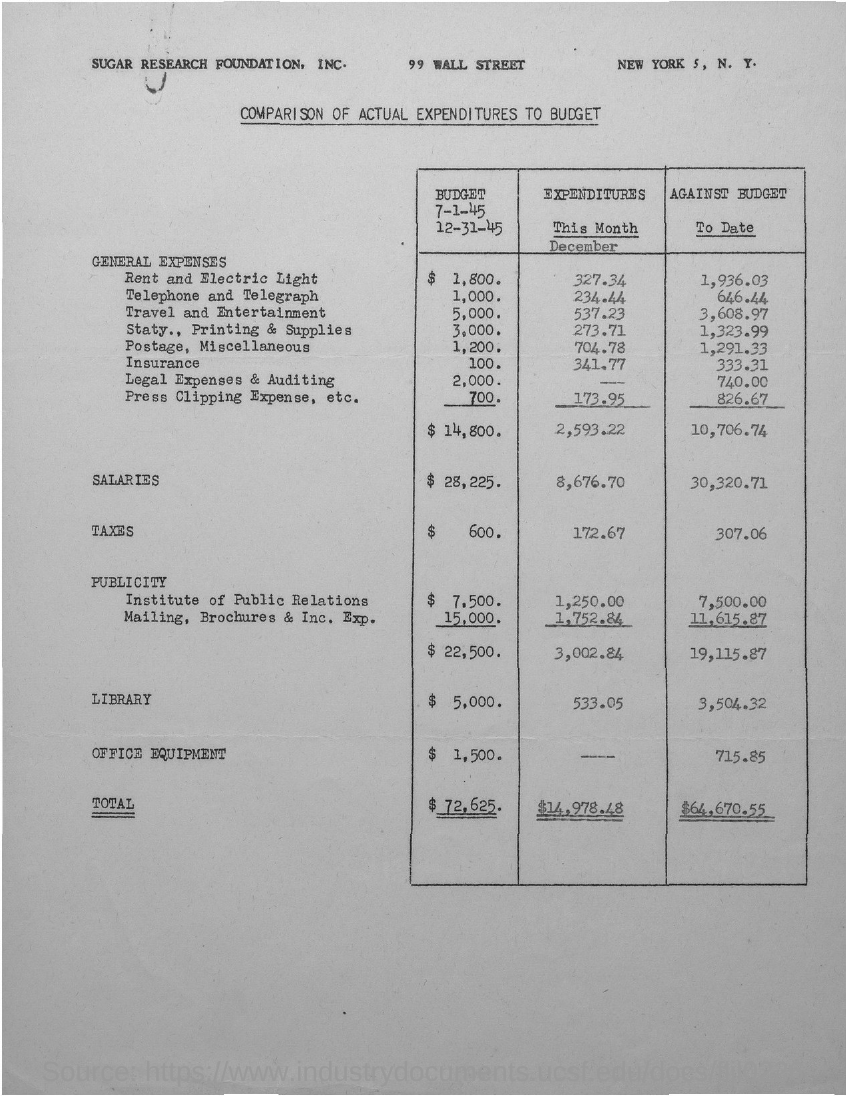Specify some key components in this picture. The Sugar Research Foundation is located in New York City. The expenditure for telephone and telegraph is 234.44... The budget for rent and electricity is $1,800. The total budget is $72,625. 